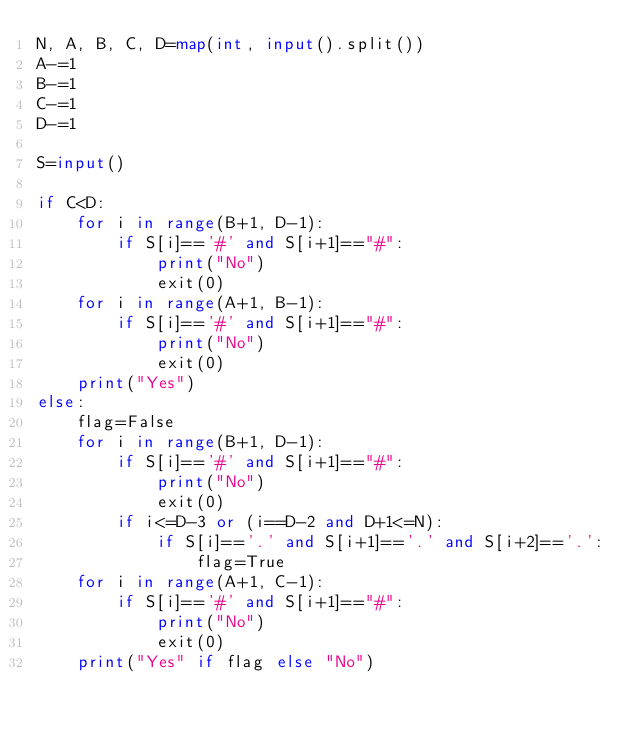<code> <loc_0><loc_0><loc_500><loc_500><_Python_>N, A, B, C, D=map(int, input().split())
A-=1
B-=1
C-=1
D-=1

S=input()

if C<D:
    for i in range(B+1, D-1):
        if S[i]=='#' and S[i+1]=="#":
            print("No")
            exit(0)
    for i in range(A+1, B-1):
        if S[i]=='#' and S[i+1]=="#":
            print("No")
            exit(0)
    print("Yes")
else:
    flag=False
    for i in range(B+1, D-1):
        if S[i]=='#' and S[i+1]=="#":
            print("No")
            exit(0)
        if i<=D-3 or (i==D-2 and D+1<=N):
            if S[i]=='.' and S[i+1]=='.' and S[i+2]=='.':
                flag=True
    for i in range(A+1, C-1):
        if S[i]=='#' and S[i+1]=="#":
            print("No")
            exit(0)
    print("Yes" if flag else "No")</code> 